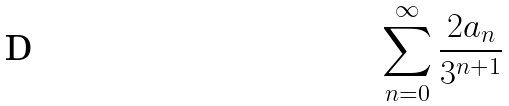Convert formula to latex. <formula><loc_0><loc_0><loc_500><loc_500>\sum _ { n = 0 } ^ { \infty } \frac { 2 a _ { n } } { 3 ^ { n + 1 } }</formula> 